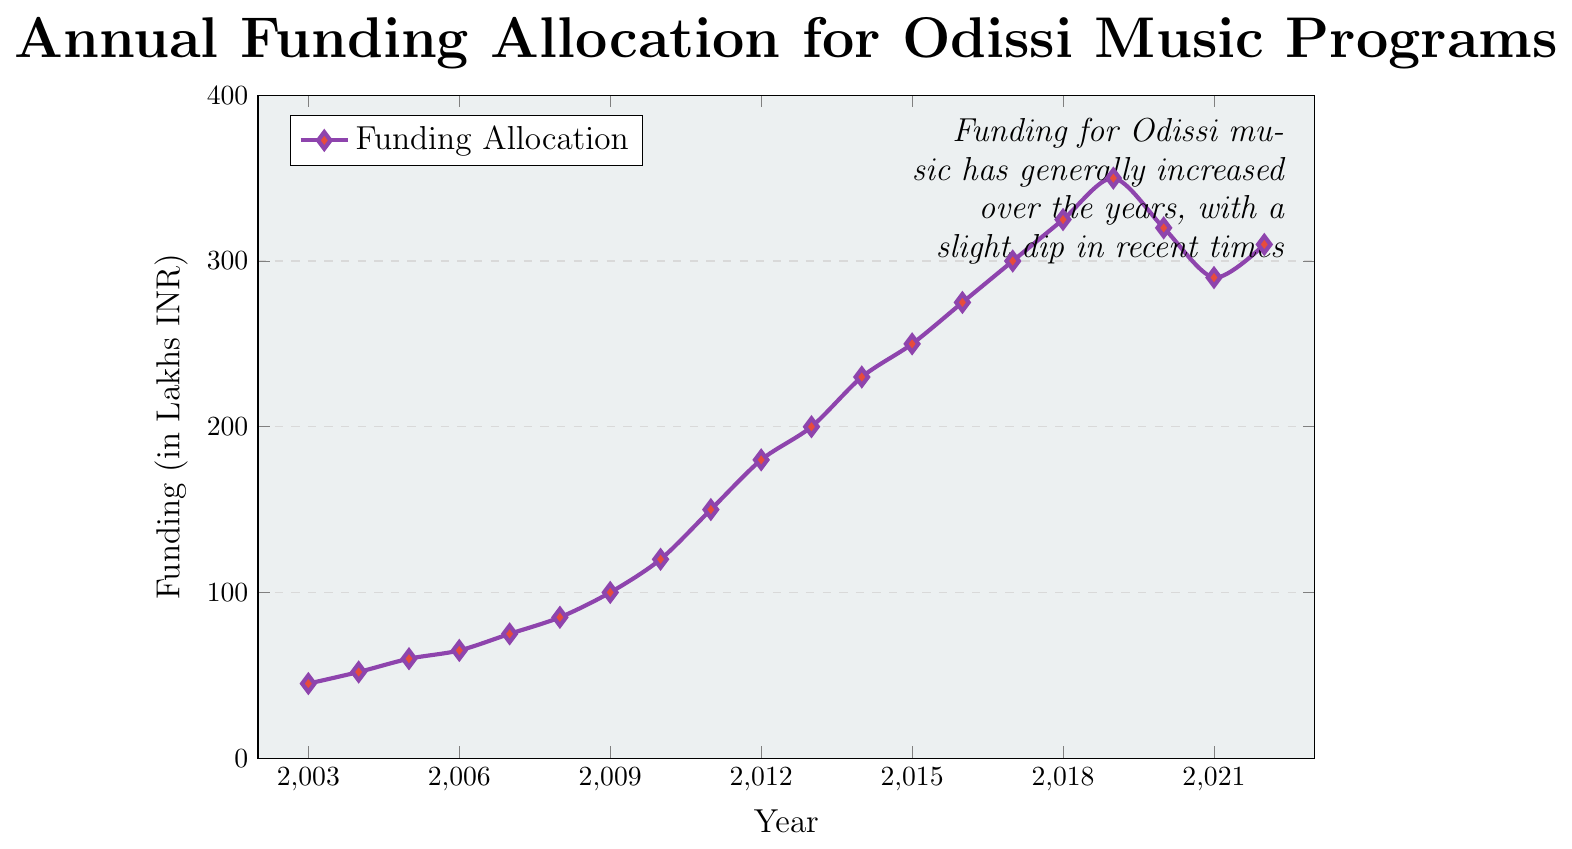What's the overall trend of funding allocation for Odissi music programs from 2003 to 2022? The overall trend shows a general increase in the funding allocation, starting from 45 Lakhs INR in 2003 and reaching up to 310 Lakhs INR in 2022. Though there is a slight dip in the last few years, the general trend over the 20 years is upward.
Answer: General increase Which year witnessed the highest funding allocation for Odissi music programs? By referring to the peak value in the line chart, 2019 witnessed the highest funding allocation with 350 Lakhs INR.
Answer: 2019 How does the funding in 2010 compare to the funding in 2005? In 2010, the funding was 120 Lakhs INR, whereas in 2005 it was 60 Lakhs INR. Comparing these values, the funding in 2010 was twice the funding in 2005.
Answer: Twice as much Between which consecutive years did the funding allocation increase the most? Observing the differences between consecutive years, the most significant increase occurred between 2011 (150 Lakhs INR) and 2012 (180 Lakhs INR), which is a 30 Lakhs INR increase.
Answer: Between 2011 and 2012 Was there any year when the funding decreased compared to the previous year? If so, which year? The funding decreased in two consecutive years: 2019 to 2020 (from 350 Lakhs INR to 320 Lakhs INR) and 2020 to 2021 (from 320 Lakhs INR to 290 Lakhs INR).
Answer: Yes, 2019-2020 and 2020-2021 What's the average funding allocation from 2015 to 2020? We need to calculate the average of the funding from 2015 to 2020: (250 + 275 + 300 + 325 + 350 + 320) / 6 = 1820 / 6 = 303.33 Lakhs INR.
Answer: 303.33 Lakhs INR How many times did the funding allocation cross the 300 Lakhs INR mark? The funding allocation crossed the 300 Lakhs INR mark in 2017, 2018, and 2019 (300, 325, and 350 Lakhs INR, respectively).
Answer: 3 times What's the difference in funding allocation between the years 2003 and 2022? The funding in 2003 was 45 Lakhs INR, and in 2022 it was 310 Lakhs INR. The difference is 310 - 45 = 265 Lakhs INR.
Answer: 265 Lakhs INR If the trend from 2003 to 2017 had continued without any dip, what could have been the projected funding for 2022? The trend from 2003 to 2017 was a continuous upward trend. The increase from 2003 to 2017 was from 45 to 300 Lakhs INR over 14 years, which is approximately (300 - 45) / 14 ≈ 18.21 Lakhs INR increase per year. Projecting for 5 more years (2017 to 2022): 300 + (5 * 18.21) ≈ 391.05 Lakhs INR.
Answer: Approximately 391.05 Lakhs INR 